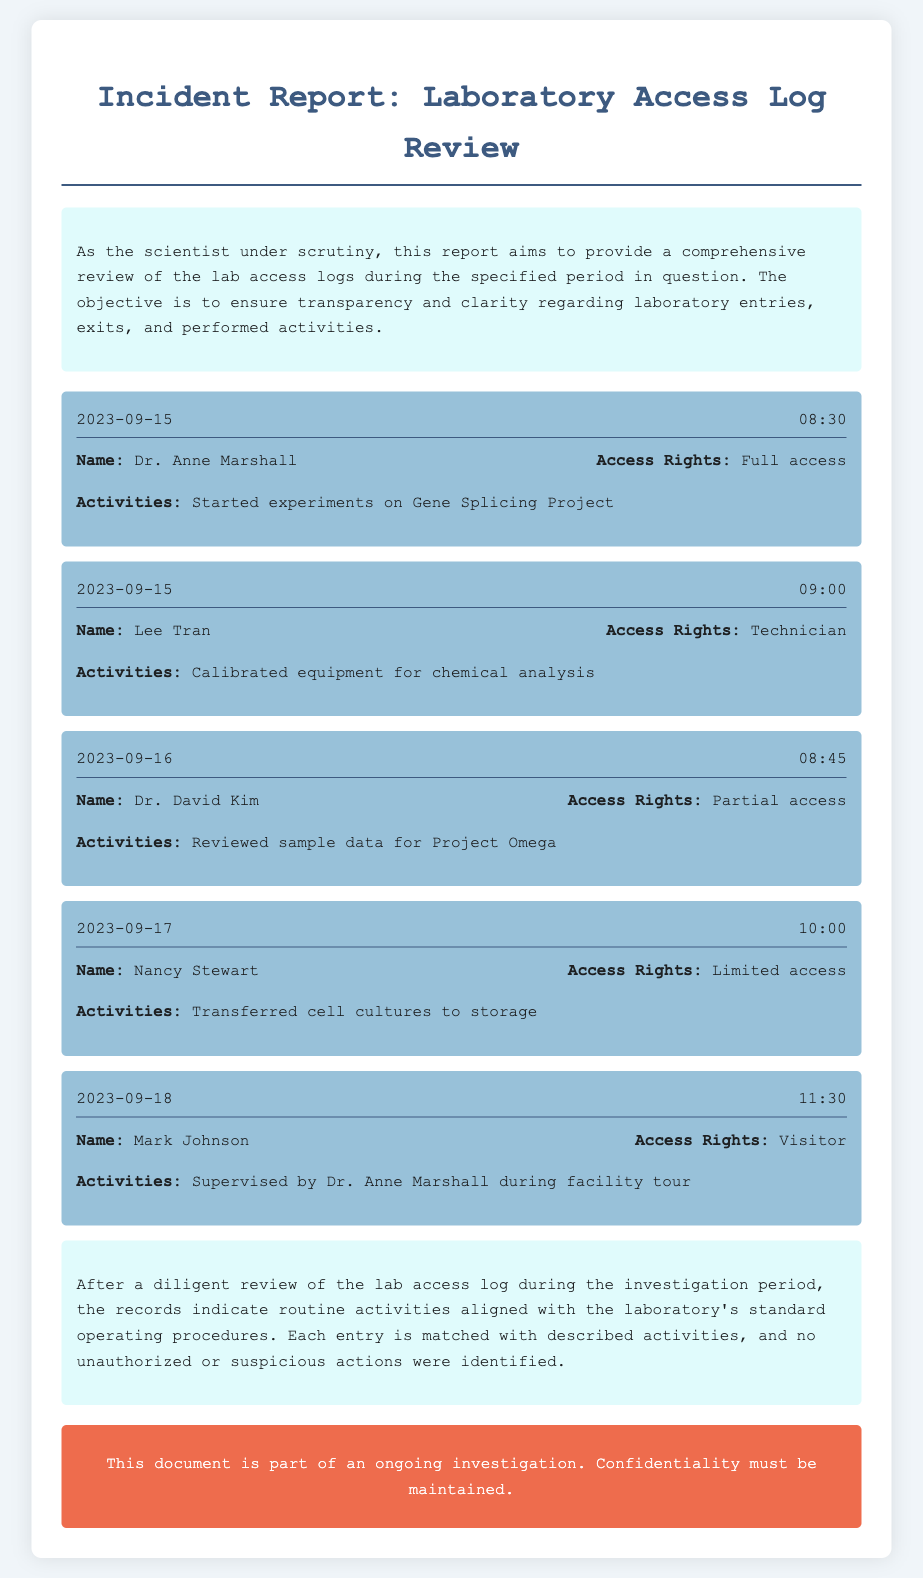What is Dr. Anne Marshall's access rights? The document states that Dr. Anne Marshall has "Full access".
Answer: Full access What activity did Lee Tran conduct on September 15? Lee Tran calibrated equipment for chemical analysis as documented in the access log.
Answer: Calibrated equipment for chemical analysis On which date did Nancy Stewart enter the laboratory? Nancy Stewart's entry is recorded on September 17 as per the log.
Answer: September 17 Who supervised Mark Johnson during the facility tour? The log specifies that Dr. Anne Marshall supervised Mark Johnson during his visit.
Answer: Dr. Anne Marshall What is the conclusion regarding the laboratory activities? The conclusion summarizes that the activities were routine and aligned with standard procedures.
Answer: Routine activities aligned with standard operating procedures How many personnel entries are documented for September 15? The document contains two personnel entries for September 15, one for Dr. Anne Marshall and one for Lee Tran.
Answer: Two What was Dr. David Kim's access rights? Dr. David Kim had "Partial access" according to the entry in the log.
Answer: Partial access What was the purpose of the warning at the end of the document? The warning emphasizes the importance of maintaining confidentiality during the ongoing investigation.
Answer: Maintain confidentiality What type of report is this document? It is classified as an incident report focused on laboratory access logs.
Answer: Incident report 